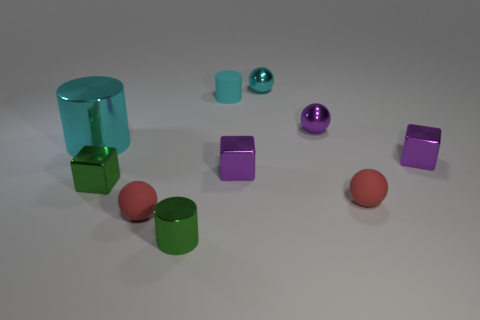Subtract 1 spheres. How many spheres are left? 3 Subtract all cylinders. How many objects are left? 7 Add 4 spheres. How many spheres exist? 8 Subtract 1 green blocks. How many objects are left? 9 Subtract all tiny yellow rubber balls. Subtract all small metallic cylinders. How many objects are left? 9 Add 3 tiny purple metal spheres. How many tiny purple metal spheres are left? 4 